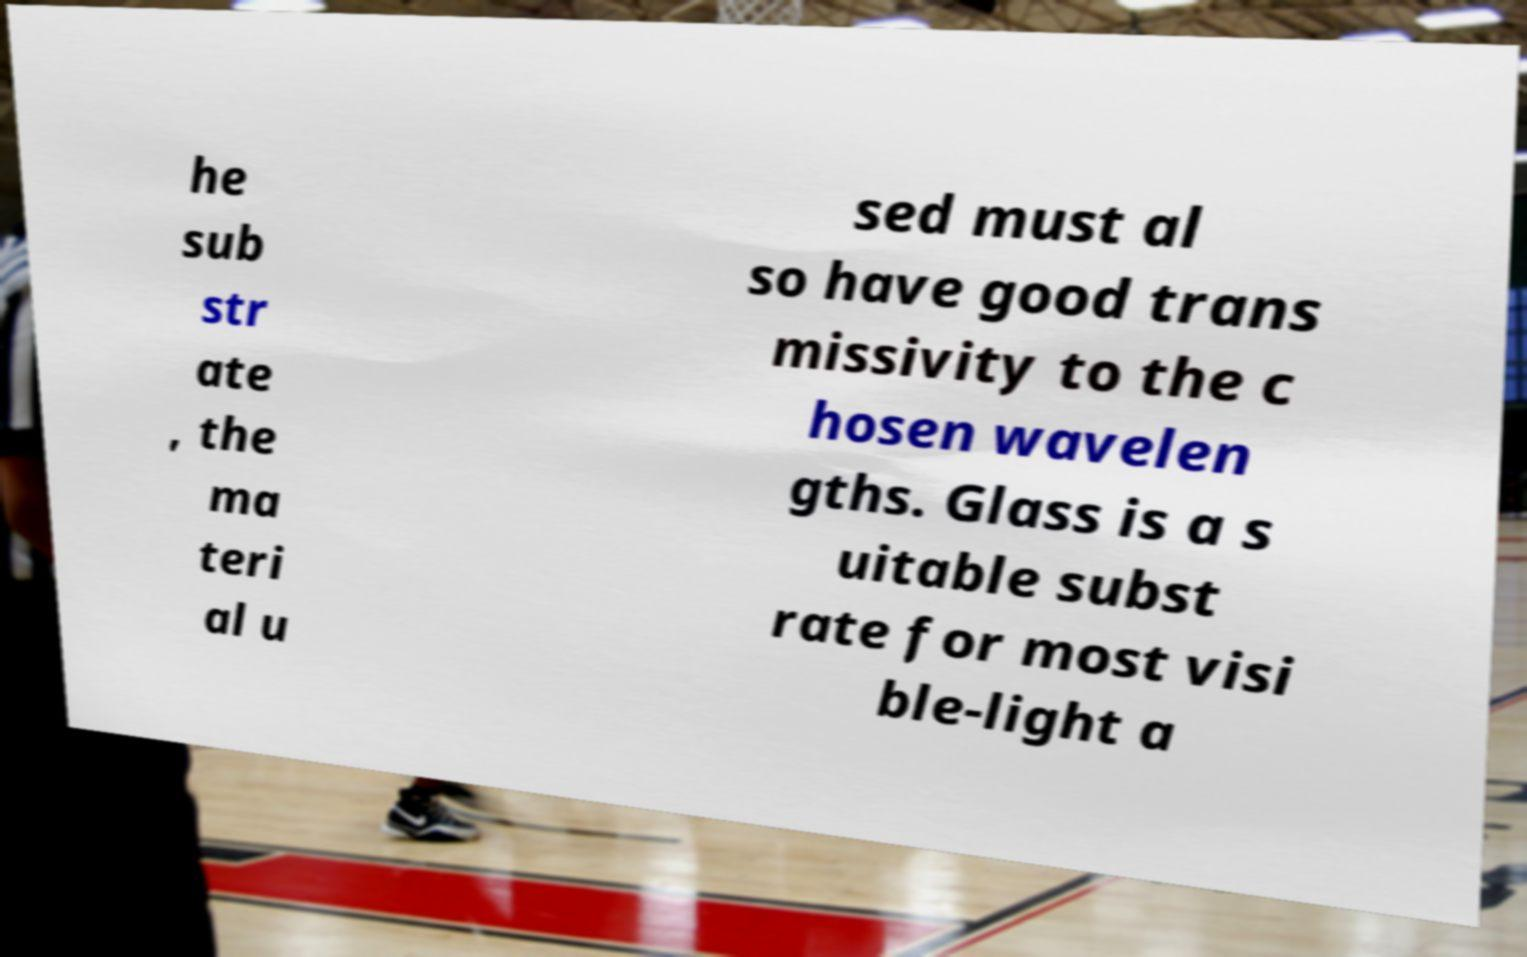Could you assist in decoding the text presented in this image and type it out clearly? he sub str ate , the ma teri al u sed must al so have good trans missivity to the c hosen wavelen gths. Glass is a s uitable subst rate for most visi ble-light a 